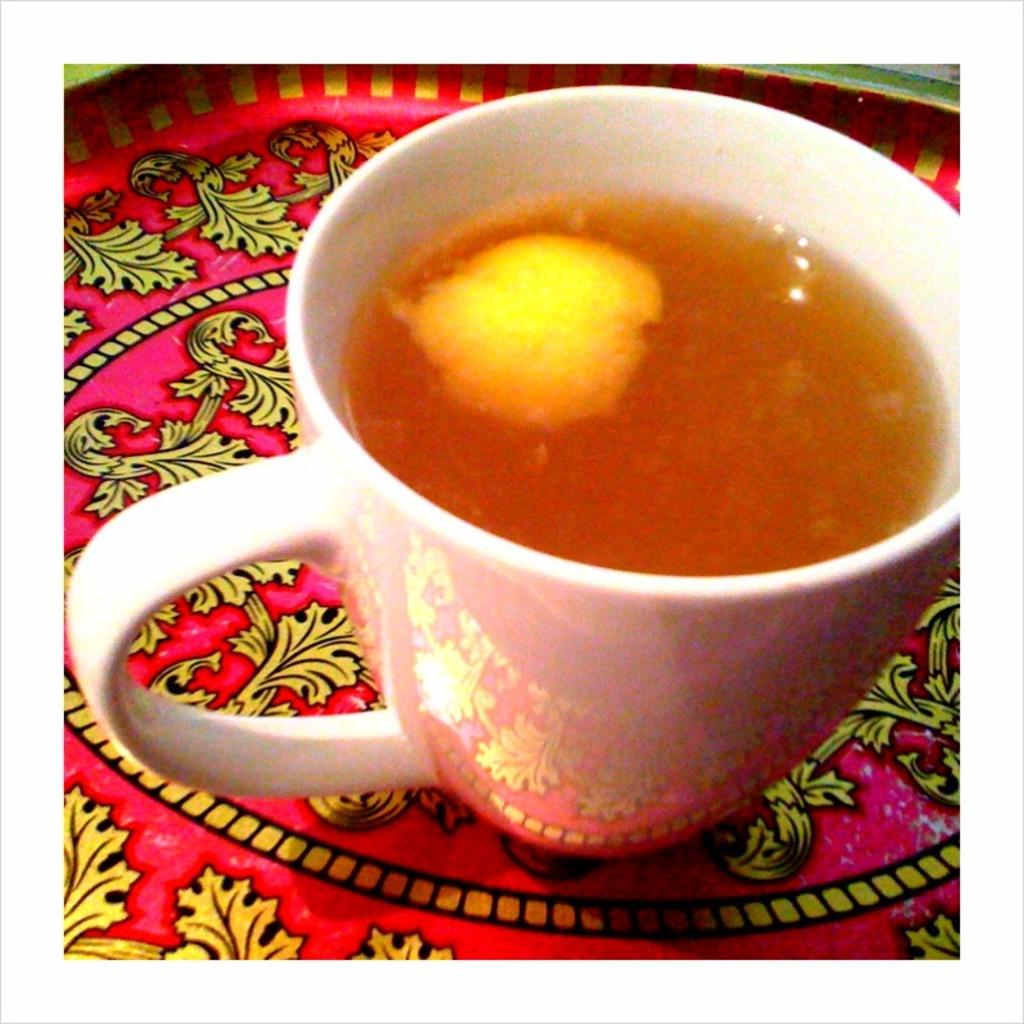What is in the cup that is visible in the image? There is a cup with liquid in the image. What is the cup placed on in the image? The cup is on an object. What type of yarn is being used to create the expansion in the image? There is no yarn or expansion present in the image; it only features a cup with liquid on an object. 